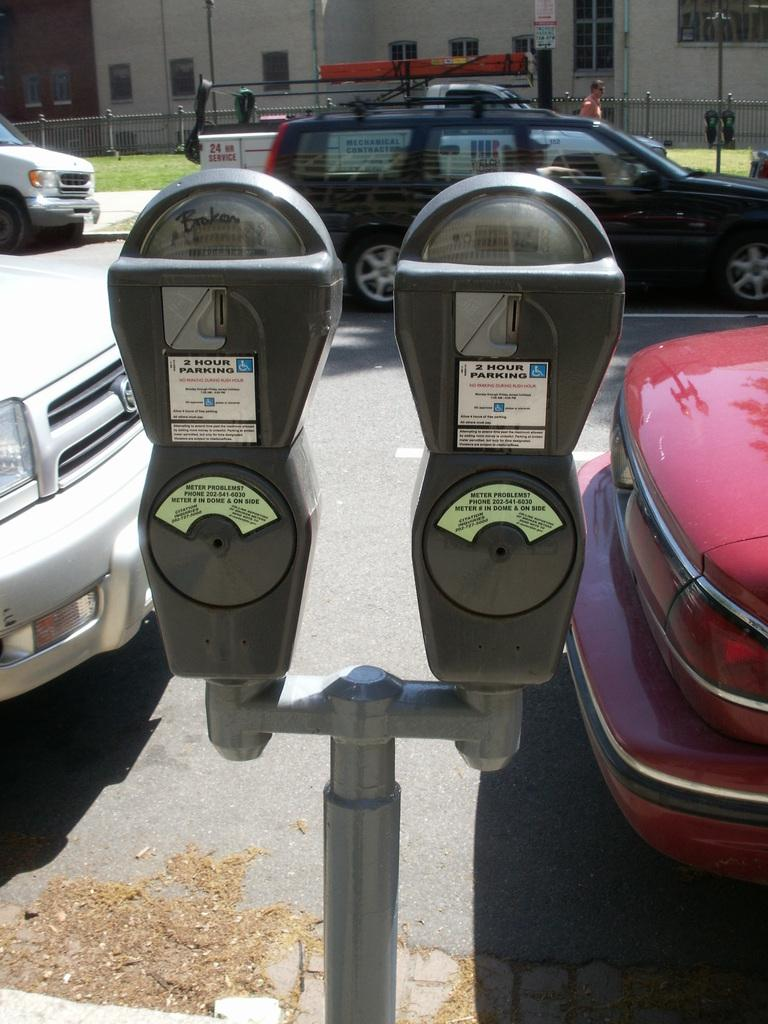<image>
Create a compact narrative representing the image presented. Two parking meters outdoors with the words "2 Hour Parking" on it. 